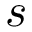<formula> <loc_0><loc_0><loc_500><loc_500>s</formula> 